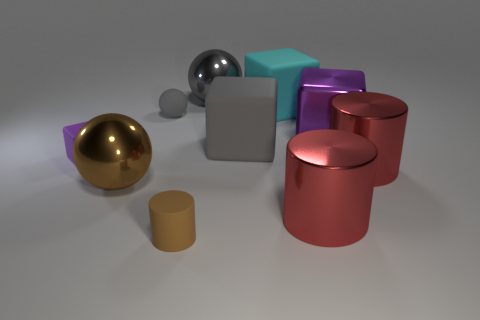Subtract all brown cubes. How many gray balls are left? 2 Subtract 1 cubes. How many cubes are left? 3 Subtract all gray blocks. How many blocks are left? 3 Subtract all big purple blocks. How many blocks are left? 3 Subtract all green spheres. Subtract all red blocks. How many spheres are left? 3 Add 8 small brown things. How many small brown things exist? 9 Subtract 1 brown balls. How many objects are left? 9 Subtract all cubes. How many objects are left? 6 Subtract all cyan objects. Subtract all small gray rubber balls. How many objects are left? 8 Add 2 gray metallic balls. How many gray metallic balls are left? 3 